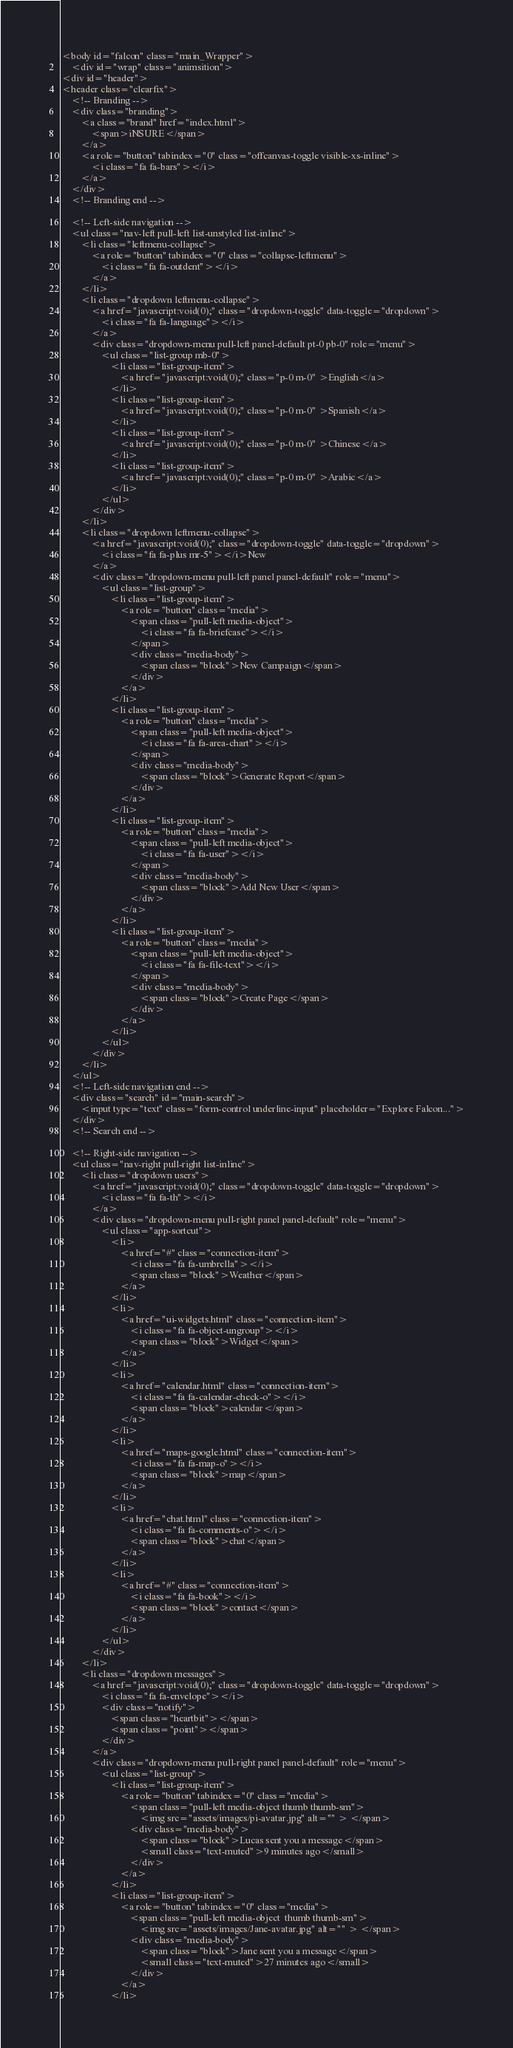Convert code to text. <code><loc_0><loc_0><loc_500><loc_500><_PHP_><body id="falcon" class="main_Wrapper">
    <div id="wrap" class="animsition">
<div id="header">
<header class="clearfix">
    <!-- Branding -->
    <div class="branding">
        <a class="brand" href="index.html">
            <span>iNSURE</span>
        </a>
        <a role="button" tabindex="0" class="offcanvas-toggle visible-xs-inline">
            <i class="fa fa-bars"></i>
        </a>
    </div>
    <!-- Branding end -->

    <!-- Left-side navigation -->
    <ul class="nav-left pull-left list-unstyled list-inline">
        <li class="leftmenu-collapse">
            <a role="button" tabindex="0" class="collapse-leftmenu">
                <i class="fa fa-outdent"></i>
            </a>
        </li>
        <li class="dropdown leftmenu-collapse">
            <a href="javascript:void(0);" class="dropdown-toggle" data-toggle="dropdown">
                <i class="fa fa-language"></i>
            </a>
            <div class="dropdown-menu pull-left panel-default pt-0 pb-0" role="menu">
                <ul class="list-group mb-0">
                    <li class="list-group-item">
                        <a href="javascript:void(0);" class="p-0 m-0" >English</a>
                    </li>
                    <li class="list-group-item">
                        <a href="javascript:void(0);" class="p-0 m-0" >Spanish</a>
                    </li>
                    <li class="list-group-item">
                        <a href="javascript:void(0);" class="p-0 m-0" >Chinese</a>
                    </li>
                    <li class="list-group-item">
                        <a href="javascript:void(0);" class="p-0 m-0" >Arabic</a>
                    </li>
                </ul>
            </div>
        </li>
        <li class="dropdown leftmenu-collapse">
            <a href="javascript:void(0);" class="dropdown-toggle" data-toggle="dropdown">
                <i class="fa fa-plus mr-5"></i>New
            </a>
            <div class="dropdown-menu pull-left panel panel-default" role="menu">
                <ul class="list-group">
                    <li class="list-group-item">
                        <a role="button" class="media">
                            <span class="pull-left media-object">
                                <i class="fa fa-briefcase"></i>
                            </span>
                            <div class="media-body">
                                <span class="block">New Campaign</span>
                            </div>
                        </a>
                    </li>
                    <li class="list-group-item">
                        <a role="button" class="media">
                            <span class="pull-left media-object">
                                <i class="fa fa-area-chart"></i>
                            </span>
                            <div class="media-body">
                                <span class="block">Generate Report</span>
                            </div>
                        </a>
                    </li>
                    <li class="list-group-item">
                        <a role="button" class="media">
                            <span class="pull-left media-object">
                                <i class="fa fa-user"></i>
                            </span>
                            <div class="media-body">
                                <span class="block">Add New User</span>
                            </div>
                        </a>
                    </li>
                    <li class="list-group-item">
                        <a role="button" class="media">
                            <span class="pull-left media-object">
                                <i class="fa fa-file-text"></i>
                            </span>
                            <div class="media-body">
                                <span class="block">Create Page</span>
                            </div>
                        </a>
                    </li>
                </ul>
            </div>
        </li>
    </ul>
    <!-- Left-side navigation end -->
    <div class="search" id="main-search">
        <input type="text" class="form-control underline-input" placeholder="Explore Falcon...">
    </div>
    <!-- Search end -->

    <!-- Right-side navigation -->
    <ul class="nav-right pull-right list-inline">
        <li class="dropdown users">
            <a href="javascript:void(0);" class="dropdown-toggle" data-toggle="dropdown">
                <i class="fa fa-th"></i>
            </a>
            <div class="dropdown-menu pull-right panel panel-default" role="menu">
                <ul class="app-sortcut">
                    <li>
                        <a href="#" class="connection-item">
                            <i class="fa fa-umbrella"></i>
                            <span class="block">Weather</span>
                        </a>
                    </li>
                    <li>
                        <a href="ui-widgets.html" class="connection-item">
                            <i class="fa fa-object-ungroup"></i>
                            <span class="block">Widget</span>
                        </a>
                    </li>
                    <li>
                        <a href="calendar.html" class="connection-item">
                            <i class="fa fa-calendar-check-o"></i>
                            <span class="block">calendar</span>
                        </a>
                    </li>
                    <li>
                        <a href="maps-google.html" class="connection-item">
                            <i class="fa fa-map-o"></i>
                            <span class="block">map</span>
                        </a>
                    </li>
                    <li>
                        <a href="chat.html" class="connection-item">
                            <i class="fa fa-comments-o"></i>
                            <span class="block">chat</span>
                        </a>
                    </li>
                    <li>
                        <a href="#" class="connection-item">
                            <i class="fa fa-book"></i>
                            <span class="block">contact</span>
                        </a>
                    </li>
                </ul>
            </div>
        </li>
        <li class="dropdown messages">
            <a href="javascript:void(0);" class="dropdown-toggle" data-toggle="dropdown">
                <i class="fa fa-envelope"></i>
                <div class="notify">
                    <span class="heartbit"></span>
                    <span class="point"></span>
                </div>
            </a>
            <div class="dropdown-menu pull-right panel panel-default" role="menu">
                <ul class="list-group">
                    <li class="list-group-item">
                        <a role="button" tabindex="0" class="media">
                            <span class="pull-left media-object thumb thumb-sm">
                                <img src="assets/images/pi-avatar.jpg" alt="" > </span>
                            <div class="media-body">
                                <span class="block">Lucas sent you a message</span>
                                <small class="text-muted">9 minutes ago</small>
                            </div>
                        </a>
                    </li>
                    <li class="list-group-item">
                        <a role="button" tabindex="0" class="media">
                            <span class="pull-left media-object  thumb thumb-sm">
                                <img src="assets/images/Jane-avatar.jpg" alt="" > </span>
                            <div class="media-body">
                                <span class="block">Jane sent you a message</span>
                                <small class="text-muted">27 minutes ago</small>
                            </div>
                        </a>
                    </li></code> 